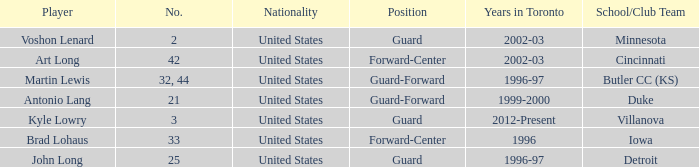What player played guard for toronto in 1996-97? John Long. 